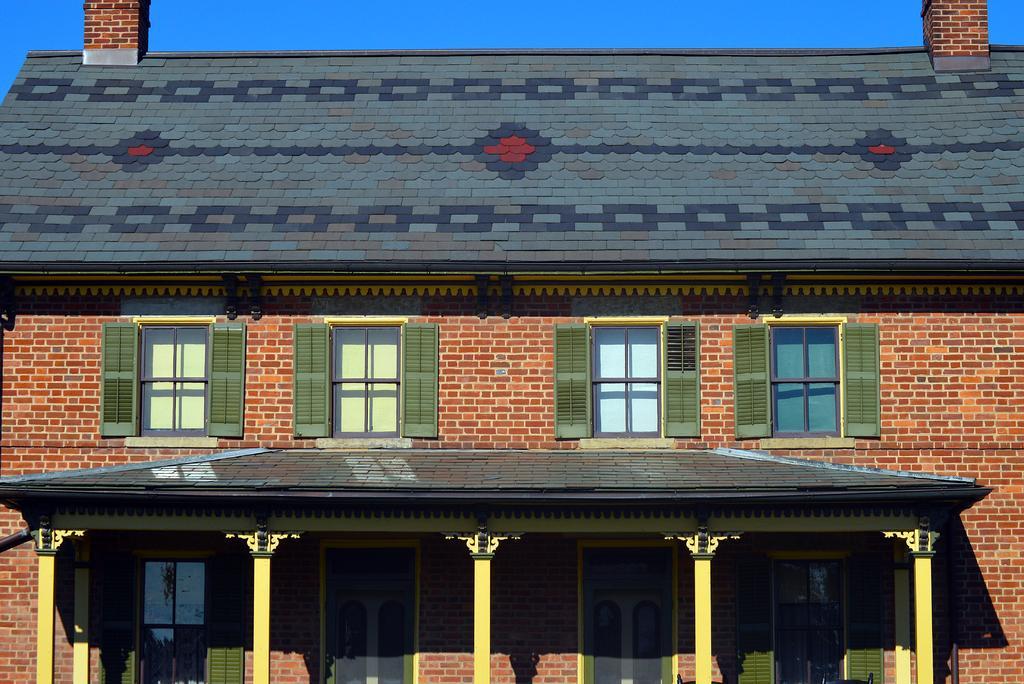Please provide a concise description of this image. In the picture there is a house,it has four windows and four doors. The house is made up of bricks,in the background there is a sky. 